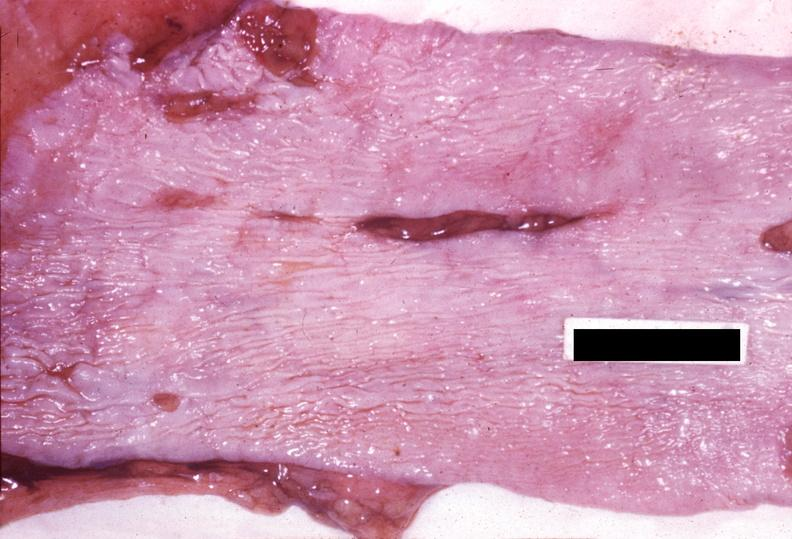does atrophy show esophagus, mallory-weiss tears?
Answer the question using a single word or phrase. No 